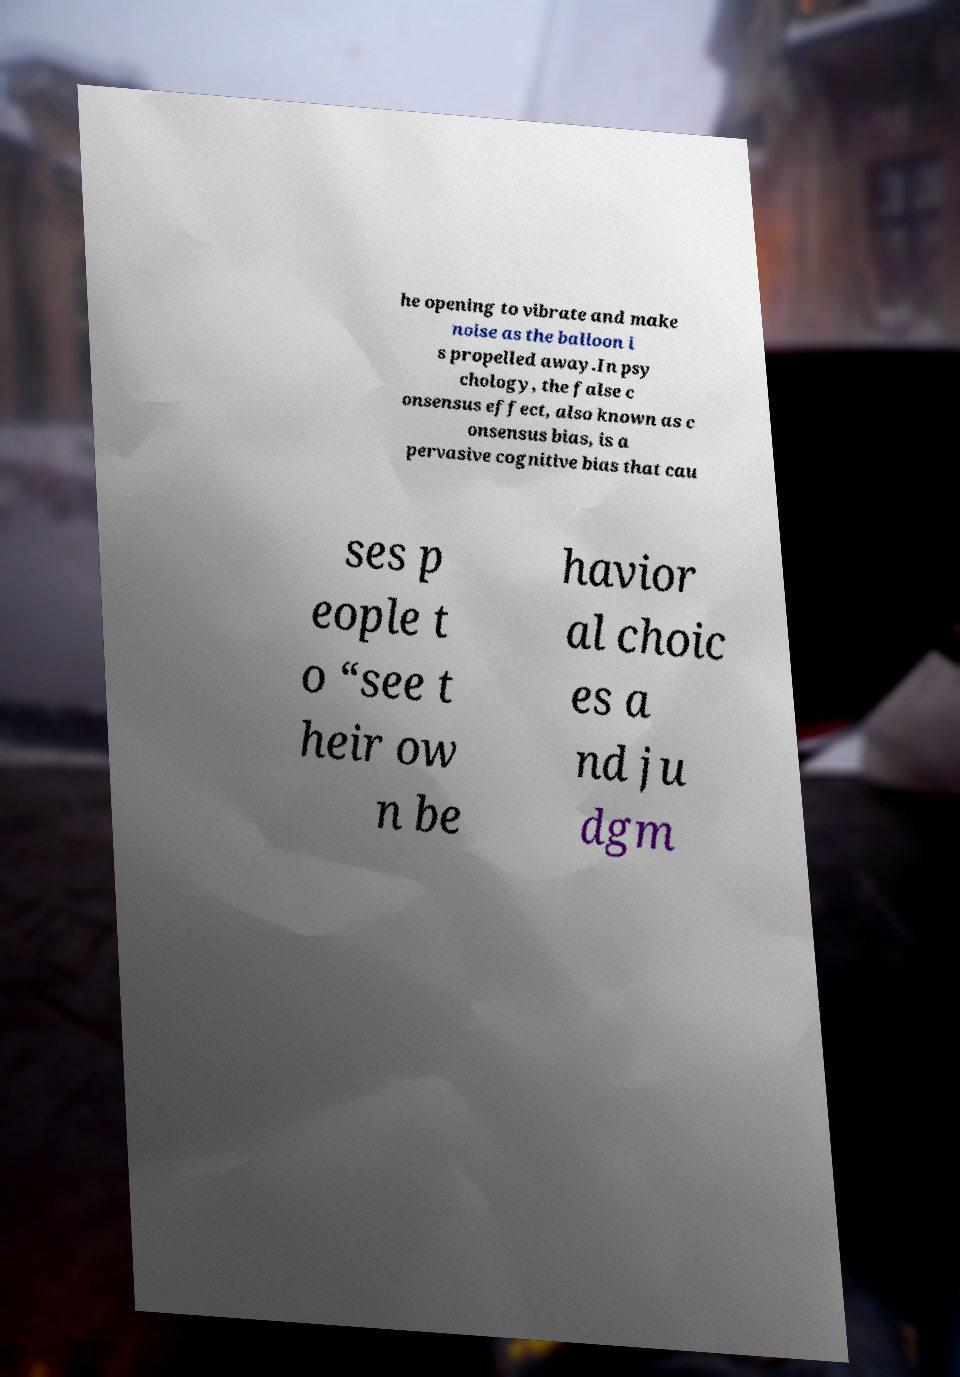What messages or text are displayed in this image? I need them in a readable, typed format. he opening to vibrate and make noise as the balloon i s propelled away.In psy chology, the false c onsensus effect, also known as c onsensus bias, is a pervasive cognitive bias that cau ses p eople t o “see t heir ow n be havior al choic es a nd ju dgm 